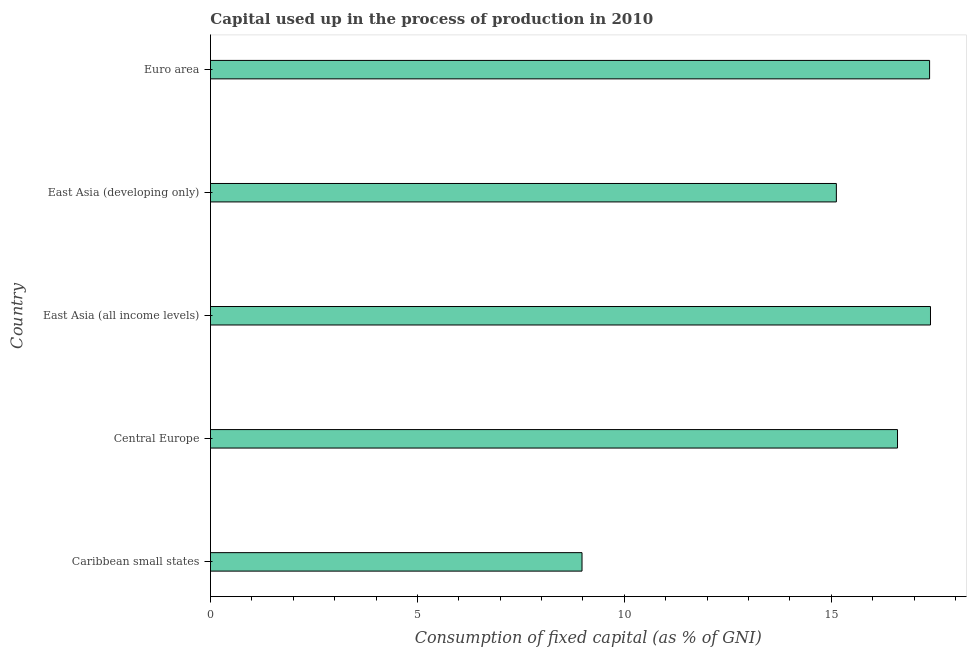Does the graph contain any zero values?
Provide a succinct answer. No. What is the title of the graph?
Provide a succinct answer. Capital used up in the process of production in 2010. What is the label or title of the X-axis?
Offer a very short reply. Consumption of fixed capital (as % of GNI). What is the label or title of the Y-axis?
Your response must be concise. Country. What is the consumption of fixed capital in Central Europe?
Your answer should be very brief. 16.6. Across all countries, what is the maximum consumption of fixed capital?
Your answer should be compact. 17.4. Across all countries, what is the minimum consumption of fixed capital?
Ensure brevity in your answer.  8.98. In which country was the consumption of fixed capital maximum?
Make the answer very short. East Asia (all income levels). In which country was the consumption of fixed capital minimum?
Offer a terse response. Caribbean small states. What is the sum of the consumption of fixed capital?
Your answer should be compact. 75.48. What is the difference between the consumption of fixed capital in East Asia (developing only) and Euro area?
Make the answer very short. -2.25. What is the average consumption of fixed capital per country?
Your answer should be very brief. 15.1. What is the median consumption of fixed capital?
Provide a succinct answer. 16.6. In how many countries, is the consumption of fixed capital greater than 17 %?
Offer a terse response. 2. What is the ratio of the consumption of fixed capital in Central Europe to that in East Asia (developing only)?
Provide a short and direct response. 1.1. Is the consumption of fixed capital in Caribbean small states less than that in Central Europe?
Make the answer very short. Yes. Is the difference between the consumption of fixed capital in East Asia (all income levels) and East Asia (developing only) greater than the difference between any two countries?
Offer a terse response. No. What is the difference between the highest and the second highest consumption of fixed capital?
Make the answer very short. 0.02. Is the sum of the consumption of fixed capital in East Asia (all income levels) and Euro area greater than the maximum consumption of fixed capital across all countries?
Your answer should be very brief. Yes. What is the difference between the highest and the lowest consumption of fixed capital?
Ensure brevity in your answer.  8.42. In how many countries, is the consumption of fixed capital greater than the average consumption of fixed capital taken over all countries?
Keep it short and to the point. 4. How many bars are there?
Your answer should be compact. 5. Are all the bars in the graph horizontal?
Ensure brevity in your answer.  Yes. How many countries are there in the graph?
Make the answer very short. 5. What is the difference between two consecutive major ticks on the X-axis?
Keep it short and to the point. 5. Are the values on the major ticks of X-axis written in scientific E-notation?
Offer a very short reply. No. What is the Consumption of fixed capital (as % of GNI) in Caribbean small states?
Your response must be concise. 8.98. What is the Consumption of fixed capital (as % of GNI) of Central Europe?
Keep it short and to the point. 16.6. What is the Consumption of fixed capital (as % of GNI) in East Asia (all income levels)?
Your answer should be very brief. 17.4. What is the Consumption of fixed capital (as % of GNI) in East Asia (developing only)?
Offer a very short reply. 15.12. What is the Consumption of fixed capital (as % of GNI) of Euro area?
Offer a terse response. 17.38. What is the difference between the Consumption of fixed capital (as % of GNI) in Caribbean small states and Central Europe?
Your answer should be compact. -7.62. What is the difference between the Consumption of fixed capital (as % of GNI) in Caribbean small states and East Asia (all income levels)?
Give a very brief answer. -8.42. What is the difference between the Consumption of fixed capital (as % of GNI) in Caribbean small states and East Asia (developing only)?
Make the answer very short. -6.15. What is the difference between the Consumption of fixed capital (as % of GNI) in Caribbean small states and Euro area?
Your answer should be very brief. -8.4. What is the difference between the Consumption of fixed capital (as % of GNI) in Central Europe and East Asia (all income levels)?
Keep it short and to the point. -0.8. What is the difference between the Consumption of fixed capital (as % of GNI) in Central Europe and East Asia (developing only)?
Provide a short and direct response. 1.48. What is the difference between the Consumption of fixed capital (as % of GNI) in Central Europe and Euro area?
Ensure brevity in your answer.  -0.78. What is the difference between the Consumption of fixed capital (as % of GNI) in East Asia (all income levels) and East Asia (developing only)?
Provide a short and direct response. 2.27. What is the difference between the Consumption of fixed capital (as % of GNI) in East Asia (all income levels) and Euro area?
Your answer should be compact. 0.02. What is the difference between the Consumption of fixed capital (as % of GNI) in East Asia (developing only) and Euro area?
Give a very brief answer. -2.25. What is the ratio of the Consumption of fixed capital (as % of GNI) in Caribbean small states to that in Central Europe?
Your response must be concise. 0.54. What is the ratio of the Consumption of fixed capital (as % of GNI) in Caribbean small states to that in East Asia (all income levels)?
Your answer should be compact. 0.52. What is the ratio of the Consumption of fixed capital (as % of GNI) in Caribbean small states to that in East Asia (developing only)?
Make the answer very short. 0.59. What is the ratio of the Consumption of fixed capital (as % of GNI) in Caribbean small states to that in Euro area?
Offer a very short reply. 0.52. What is the ratio of the Consumption of fixed capital (as % of GNI) in Central Europe to that in East Asia (all income levels)?
Ensure brevity in your answer.  0.95. What is the ratio of the Consumption of fixed capital (as % of GNI) in Central Europe to that in East Asia (developing only)?
Offer a terse response. 1.1. What is the ratio of the Consumption of fixed capital (as % of GNI) in Central Europe to that in Euro area?
Offer a very short reply. 0.95. What is the ratio of the Consumption of fixed capital (as % of GNI) in East Asia (all income levels) to that in East Asia (developing only)?
Give a very brief answer. 1.15. What is the ratio of the Consumption of fixed capital (as % of GNI) in East Asia (all income levels) to that in Euro area?
Offer a very short reply. 1. What is the ratio of the Consumption of fixed capital (as % of GNI) in East Asia (developing only) to that in Euro area?
Your response must be concise. 0.87. 